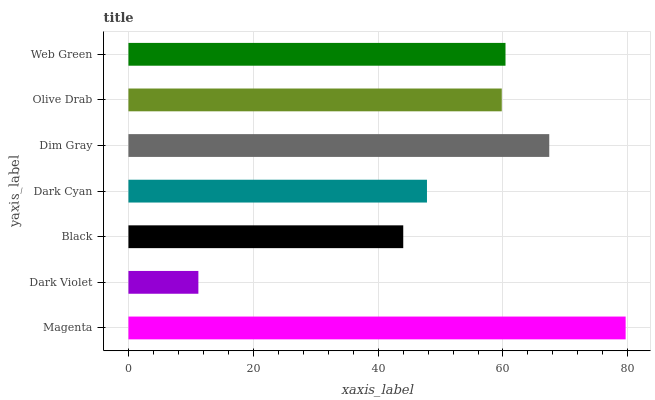Is Dark Violet the minimum?
Answer yes or no. Yes. Is Magenta the maximum?
Answer yes or no. Yes. Is Black the minimum?
Answer yes or no. No. Is Black the maximum?
Answer yes or no. No. Is Black greater than Dark Violet?
Answer yes or no. Yes. Is Dark Violet less than Black?
Answer yes or no. Yes. Is Dark Violet greater than Black?
Answer yes or no. No. Is Black less than Dark Violet?
Answer yes or no. No. Is Olive Drab the high median?
Answer yes or no. Yes. Is Olive Drab the low median?
Answer yes or no. Yes. Is Dim Gray the high median?
Answer yes or no. No. Is Magenta the low median?
Answer yes or no. No. 